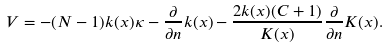<formula> <loc_0><loc_0><loc_500><loc_500>V = - ( N - 1 ) k ( x ) \kappa - \frac { \partial } { \partial n } k ( x ) - \frac { 2 k ( x ) ( C + 1 ) } { K ( x ) } \frac { \partial } { \partial n } K ( x ) .</formula> 